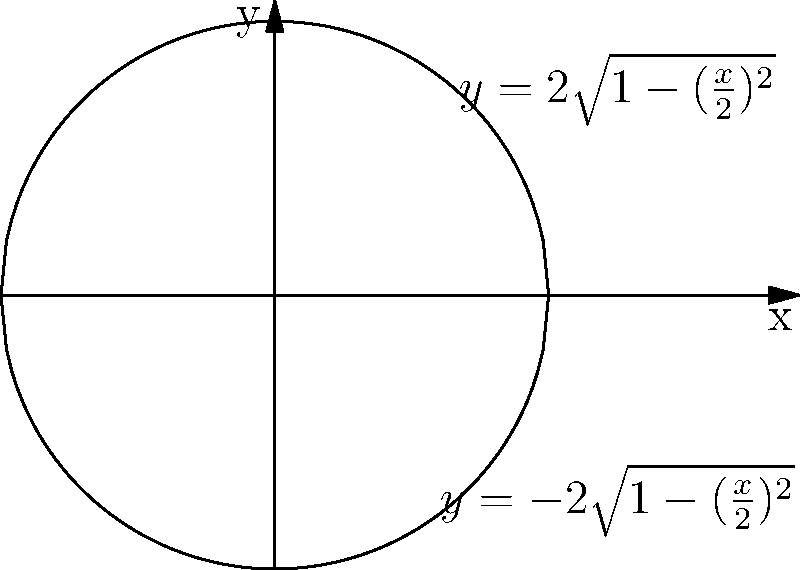As a poker forum moderator, you're interested in the geometry of poker chips. A stack of poker chips can be approximated by rotating the region bounded by $y = \pm 2\sqrt{1-(\frac{x}{2})^2}$ around the y-axis. What is the volume of this poker chip stack in cubic units? To find the volume of the solid formed by rotating this region around the y-axis, we'll use the washer method:

1) The curve is symmetric about the x-axis, so we can integrate from 0 to 2 and double the result.

2) We need to express x in terms of y:
   $y^2 = 4(1-(\frac{x}{2})^2)$
   $(\frac{x}{2})^2 = 1 - \frac{y^2}{4}$
   $x^2 = 4 - y^2$

3) The volume formula using the washer method is:
   $V = 2\pi \int_0^2 x^2 dy$

4) Substituting our expression for $x^2$:
   $V = 2\pi \int_0^2 (4 - y^2) dy$

5) Evaluating the integral:
   $V = 2\pi [4y - \frac{y^3}{3}]_0^2$
   $V = 2\pi [(8 - \frac{8}{3}) - (0 - 0)]$
   $V = 2\pi [\frac{16}{3}]$
   $V = \frac{32\pi}{3}$

Therefore, the volume of the poker chip stack is $\frac{32\pi}{3}$ cubic units.
Answer: $\frac{32\pi}{3}$ cubic units 